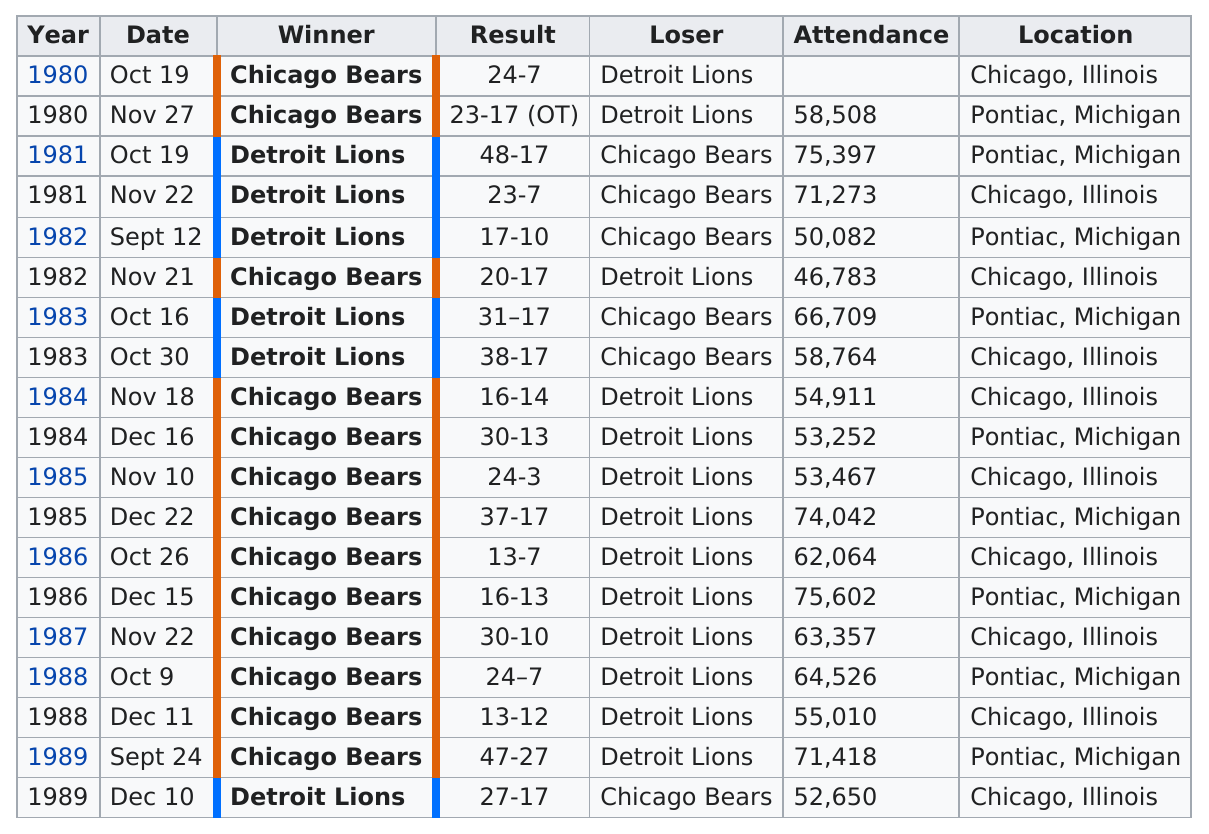Mention a couple of crucial points in this snapshot. During the 1980s, the Detroit Lions lost a total of 13 games against the Chicago Bears. There were 19 games in this rivalry that took place in the 1980s. In the 1980s, the Chicago Bears won a total of 13 games. During the 1980s, the Chicago Bears won 10 consecutive games against the Detroit Lions. The date of December 15, 1986 was attended by the most people. 